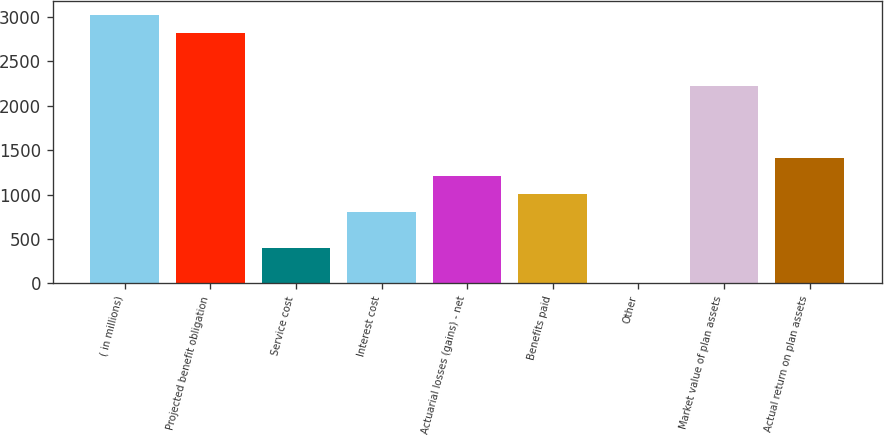Convert chart to OTSL. <chart><loc_0><loc_0><loc_500><loc_500><bar_chart><fcel>( in millions)<fcel>Projected benefit obligation<fcel>Service cost<fcel>Interest cost<fcel>Actuarial losses (gains) - net<fcel>Benefits paid<fcel>Other<fcel>Market value of plan assets<fcel>Actual return on plan assets<nl><fcel>3025<fcel>2823.4<fcel>404.2<fcel>807.4<fcel>1210.6<fcel>1009<fcel>1<fcel>2218.6<fcel>1412.2<nl></chart> 